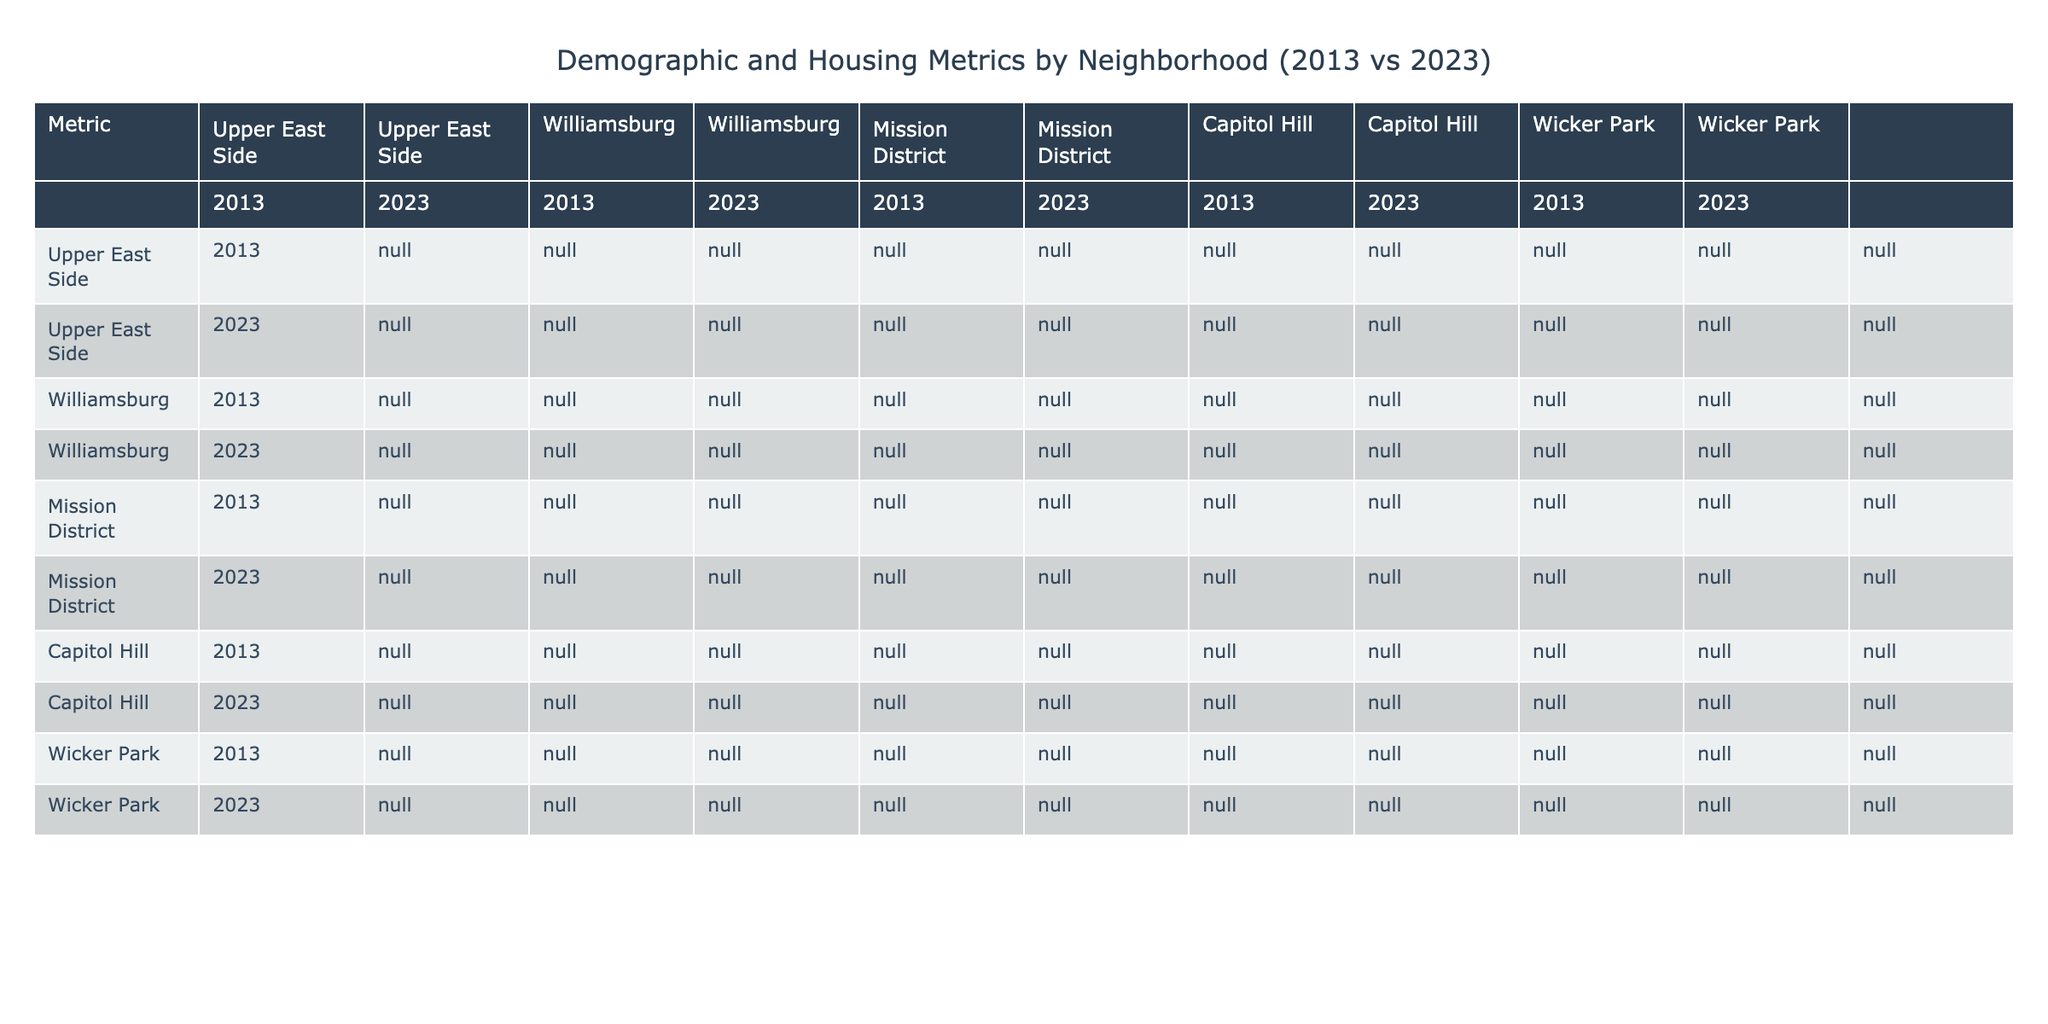What was the median income in Williamsburg in 2023? Referring to the table, the median income for Williamsburg in 2023 is listed as 88,000.
Answer: 88,000 What is the change in the average rent in the Upper East Side from 2013 to 2023? The average rent in 2013 was 2,800, and in 2023 it is 3,600. The change is 3,600 - 2,800 = 800.
Answer: 800 Did the vacancy rate in the Mission District decrease from 2013 to 2023? In 2013, the vacancy rate was 1.9%, and in 2023 it is 1.5%. Since 1.5% is less than 1.9%, the vacancy rate did decrease.
Answer: Yes What was the average rent across all neighborhoods in 2023? The average rent in 2023 for each neighborhood is 3,600 (Upper East Side) + 2,800 (Williamsburg) + 3,200 (Mission District) + 2,600 (Capitol Hill) + 2,700 (Wicker Park) = 15,900. There are 5 neighborhoods, so the average is 15,900 / 5 = 3,180.
Answer: 3,180 Which neighborhood saw the highest eviction rate in 2023? In 2023, the eviction rates for each neighborhood are 0.9% (Upper East Side), 1.5% (Williamsburg), 1.2% (Mission District), 1.1% (Capitol Hill), and 1.3% (Wicker Park). The highest eviction rate is 1.5% in Williamsburg.
Answer: Williamsburg How did the population density change in the Upper East Side from 2013 to 2023? The population density in 2013 was 105,000, and in 2023 it is 108,000. The change is 108,000 - 105,000 = 3,000.
Answer: 3,000 Is there a trend of increasing median age in all neighborhoods between 2013 and 2023? The median ages for the neighborhoods in 2013 were 42 (Upper East Side), 31 (Williamsburg), 36 (Mission District), 33 (Capitol Hill), and 32 (Wicker Park). In 2023, they are 45, 35, 39, 37, and 36, respectively. All neighborhoods show an increase in median age from 2013 to 2023.
Answer: Yes What is the total number of new construction units in Capitol Hill from 2013 to 2023? In 2013, there were 190 new construction units, and in 2023, there were 310. The total number is 190 + 310 = 500.
Answer: 500 Which neighborhood experienced the greatest increase in property value from 2013 to 2023? The property value changes were 3.5% (Upper East Side), 6.8% (Williamsburg), 4.2% (Mission District), 3.9% (Capitol Hill), and 4.5% (Wicker Park). The greatest increase is 6.8% in Williamsburg.
Answer: Williamsburg What was the median income in rent-controlled units in 2013 compared to 2023 for Wicker Park? In 2013 the median income was 70,000, and in 2023 it is 92,000. The change is 92,000 - 70,000 = 22,000.
Answer: 22,000 